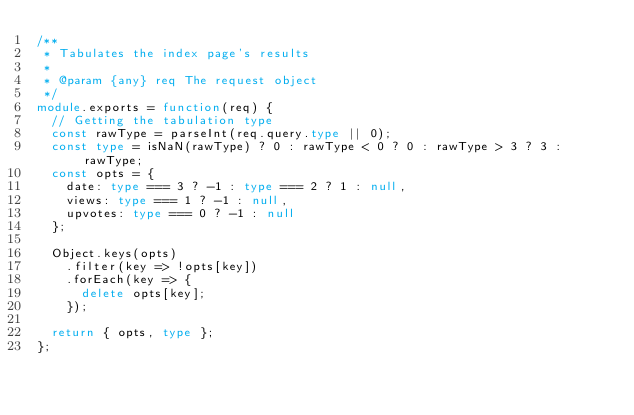<code> <loc_0><loc_0><loc_500><loc_500><_TypeScript_>/**
 * Tabulates the index page's results
 *
 * @param {any} req The request object
 */
module.exports = function(req) {
  // Getting the tabulation type
  const rawType = parseInt(req.query.type || 0);
  const type = isNaN(rawType) ? 0 : rawType < 0 ? 0 : rawType > 3 ? 3 : rawType;
  const opts = {
    date: type === 3 ? -1 : type === 2 ? 1 : null,
    views: type === 1 ? -1 : null,
    upvotes: type === 0 ? -1 : null
  };

  Object.keys(opts)
    .filter(key => !opts[key])
    .forEach(key => {
      delete opts[key];
    });

  return { opts, type };
};
</code> 